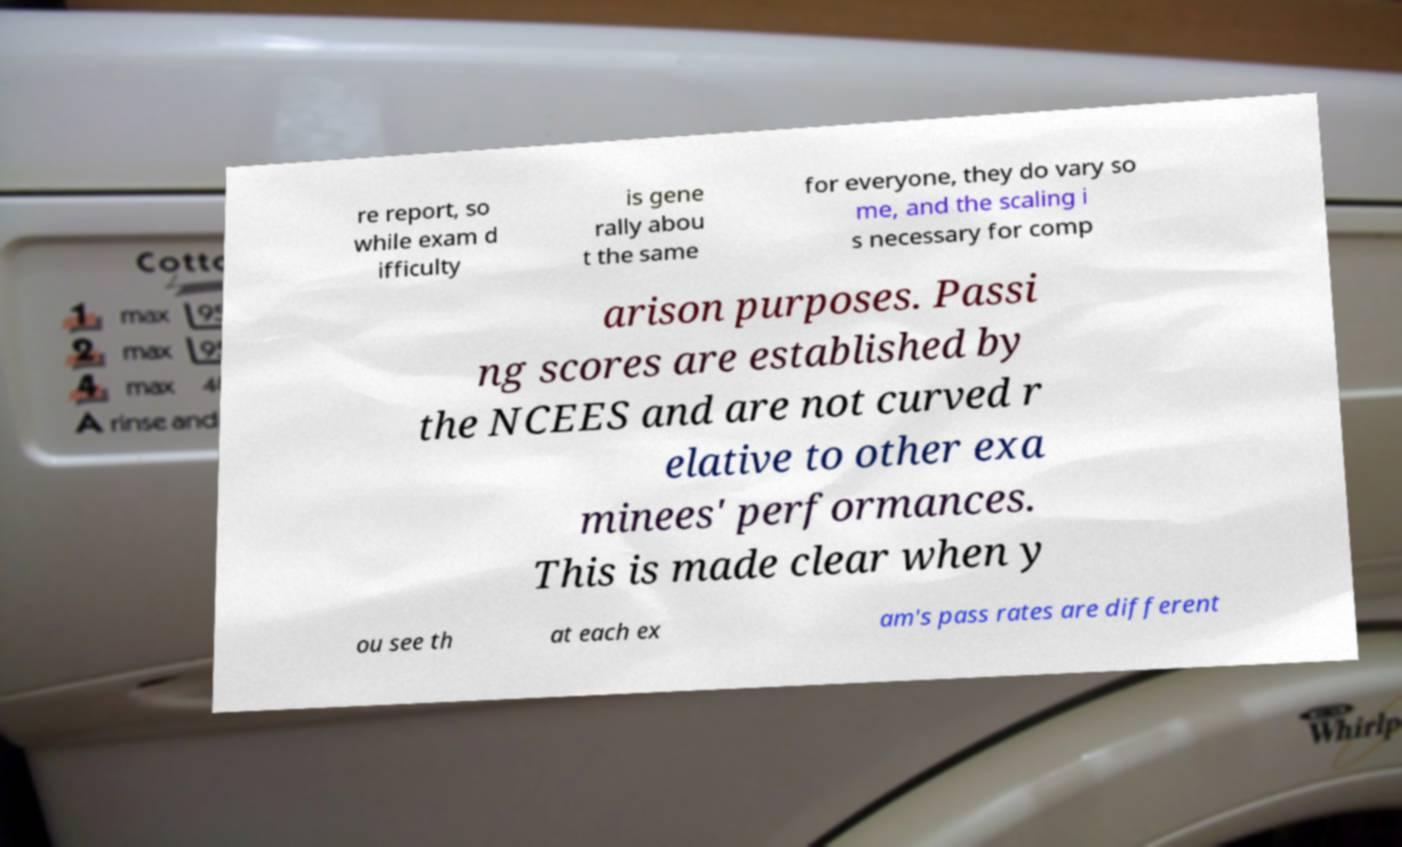For documentation purposes, I need the text within this image transcribed. Could you provide that? re report, so while exam d ifficulty is gene rally abou t the same for everyone, they do vary so me, and the scaling i s necessary for comp arison purposes. Passi ng scores are established by the NCEES and are not curved r elative to other exa minees' performances. This is made clear when y ou see th at each ex am's pass rates are different 